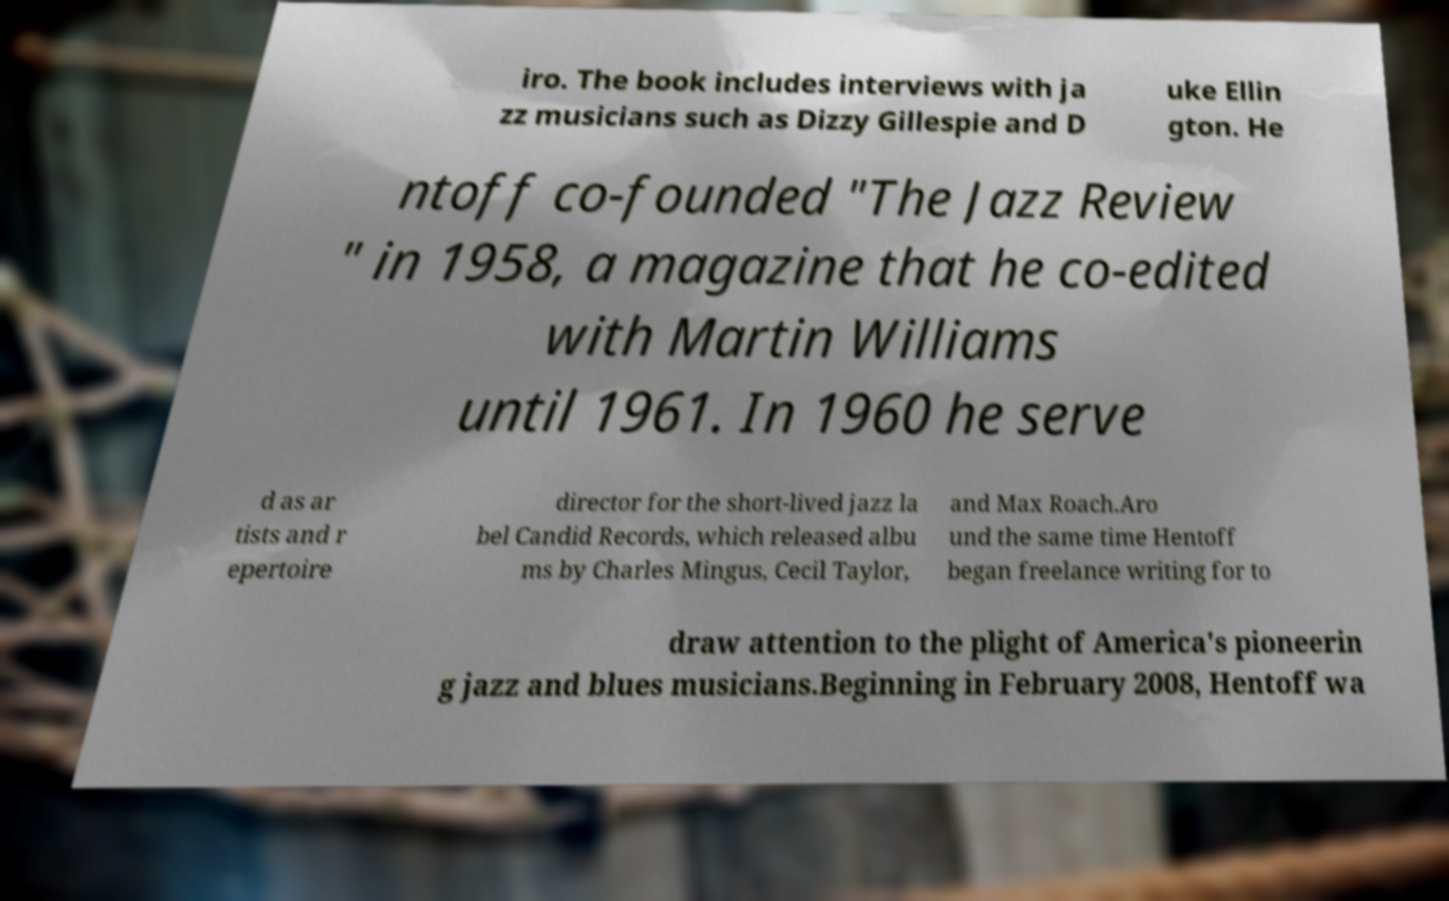Could you extract and type out the text from this image? iro. The book includes interviews with ja zz musicians such as Dizzy Gillespie and D uke Ellin gton. He ntoff co-founded "The Jazz Review " in 1958, a magazine that he co-edited with Martin Williams until 1961. In 1960 he serve d as ar tists and r epertoire director for the short-lived jazz la bel Candid Records, which released albu ms by Charles Mingus, Cecil Taylor, and Max Roach.Aro und the same time Hentoff began freelance writing for to draw attention to the plight of America's pioneerin g jazz and blues musicians.Beginning in February 2008, Hentoff wa 